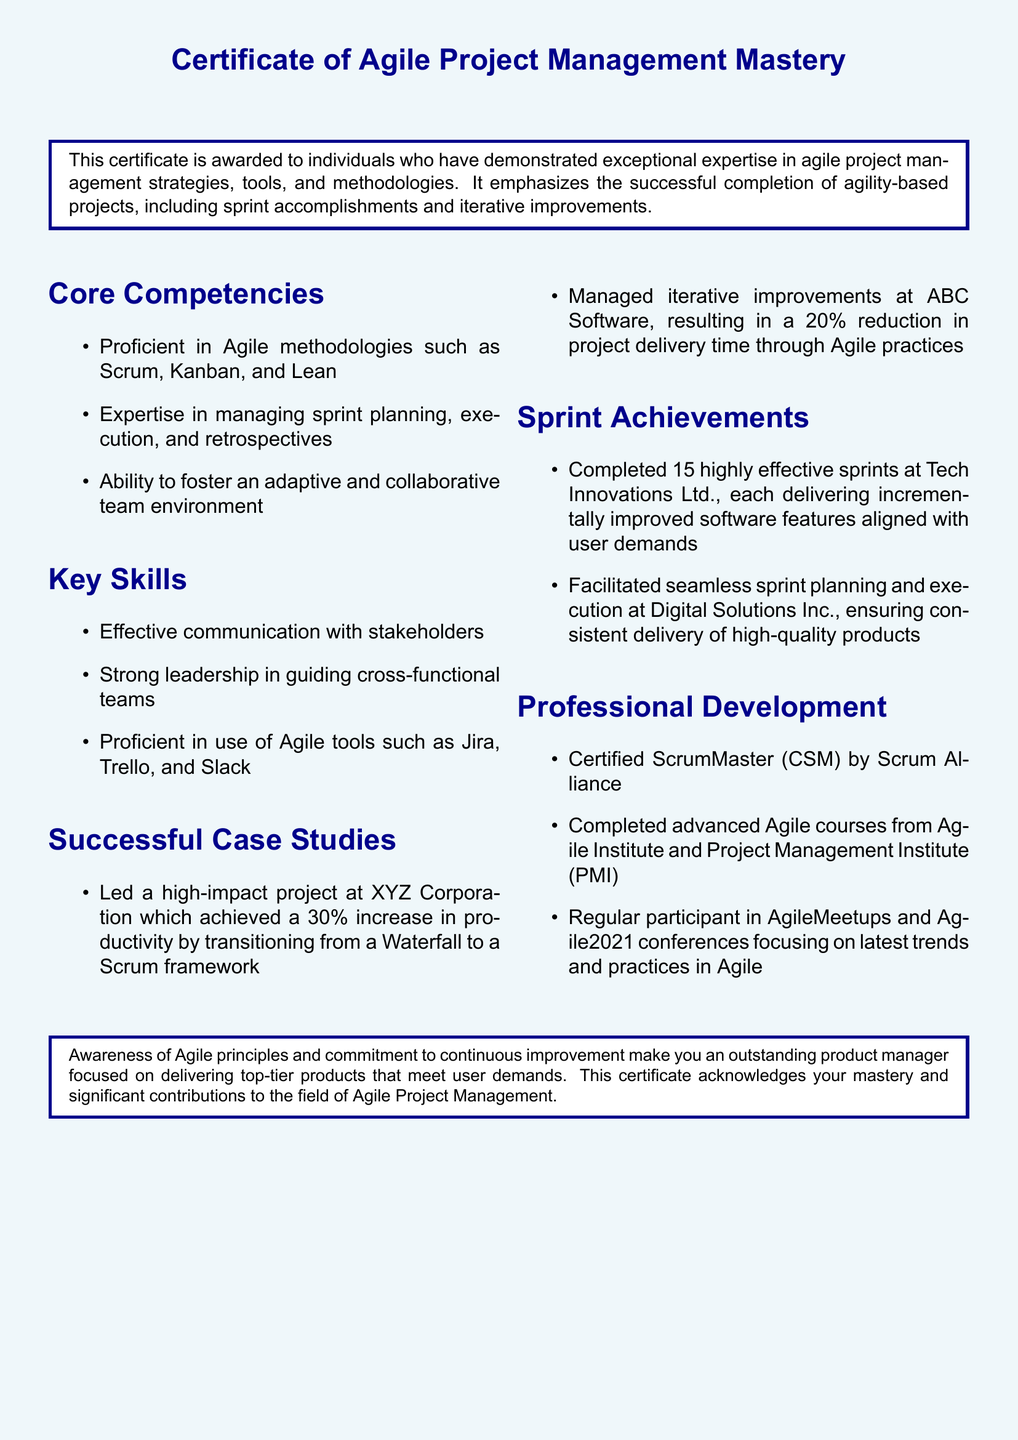what is the title of the certificate? The title of the certificate is stated at the top of the document and highlights the achievement recognized.
Answer: Certificate of Agile Project Management Mastery how many sprints were completed at Tech Innovations Ltd.? The document specifies the total number of sprints completed during the experience at this company as a quantifiable achievement.
Answer: 15 which Agile methodologies are mentioned as core competencies? The document lists various methodologies that represent the main skill areas of the individual, capturing their expertise.
Answer: Scrum, Kanban, and Lean what percentage increase in productivity was achieved at XYZ Corporation? The document provides a specific percentage reflecting the improvement in productivity due to an agile transition.
Answer: 30% name one Agile tool mentioned in the key skills section. The document lists tools that are relevant to the agile project management field, recognizing practical competencies.
Answer: Jira what type of development is highlighted under professional development? The document describes types of qualifications that reflect the learning and recognition of the individual in the Agile arena.
Answer: Certified ScrumMaster (CSM) what was the result of managing iterative improvements at ABC Software? The document quantifies the outcome of work done in this case study, emphasizing project efficiency.
Answer: 20% reduction in project delivery time which event is mentioned as a regular participant activity? The document includes various activities that showcase continuous learning and engagement within the Agile community.
Answer: AgileMeetups 